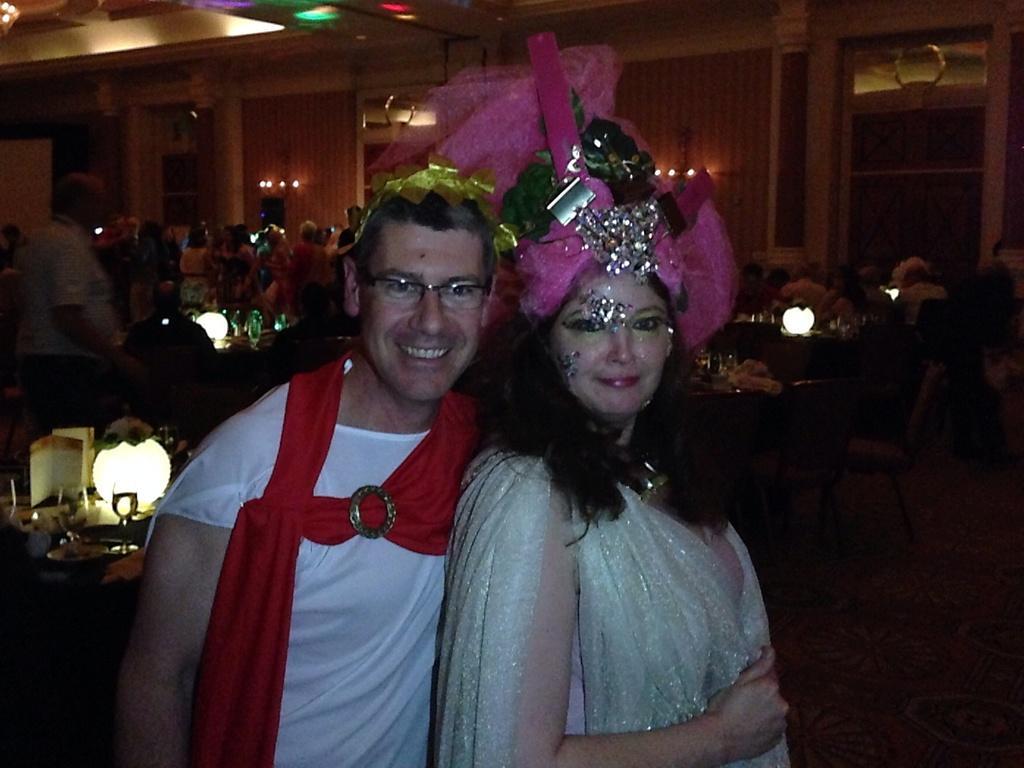Can you describe this image briefly? This picture is clicked inside. In the foreground we can see the two persons smiling and standing on the ground. In the background we can see the group of people , tables chairs and many other objects and we can see the wall, lights, roof and some other objects. 